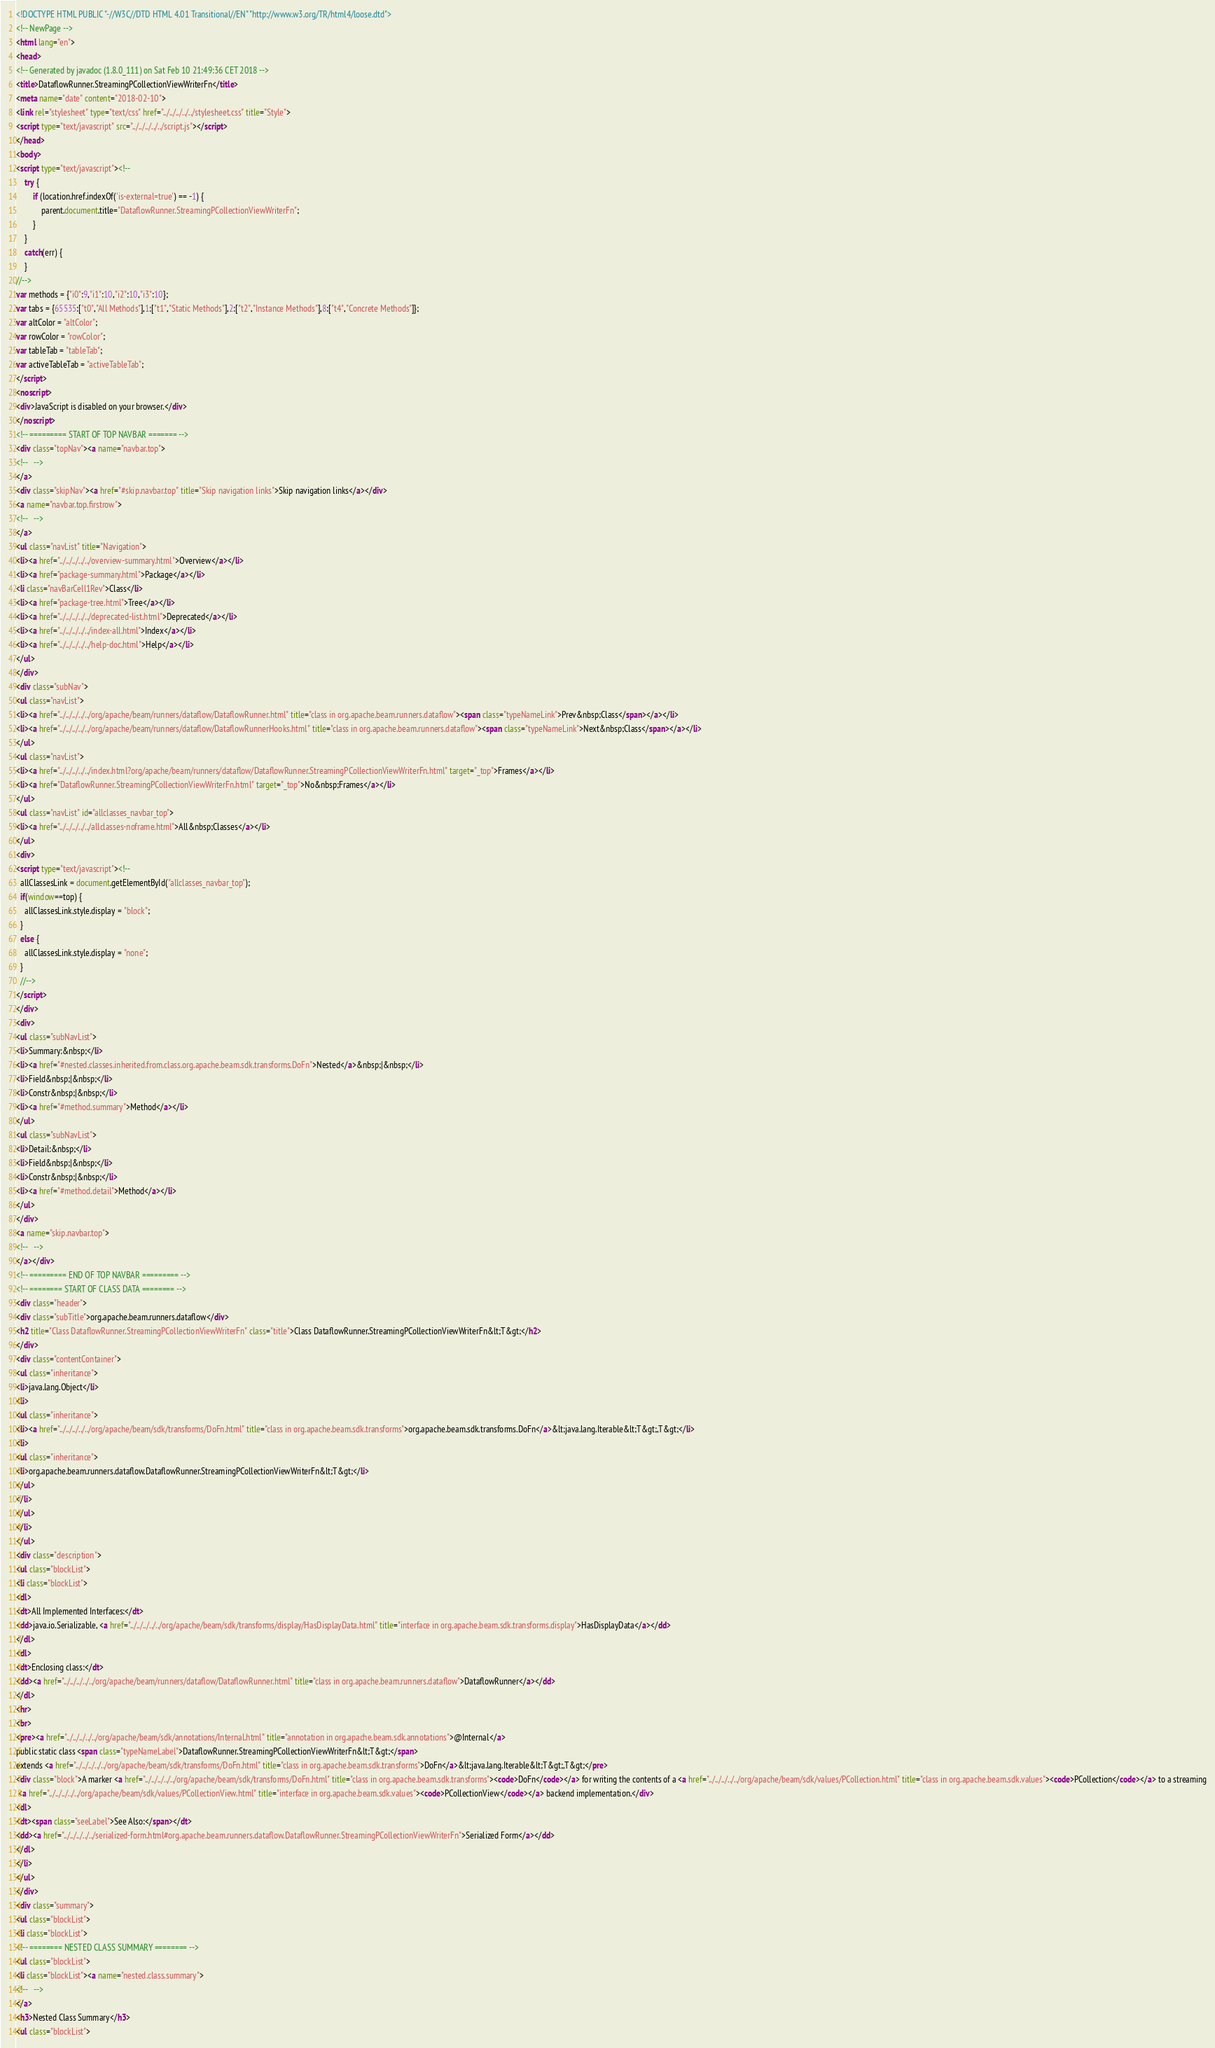<code> <loc_0><loc_0><loc_500><loc_500><_HTML_><!DOCTYPE HTML PUBLIC "-//W3C//DTD HTML 4.01 Transitional//EN" "http://www.w3.org/TR/html4/loose.dtd">
<!-- NewPage -->
<html lang="en">
<head>
<!-- Generated by javadoc (1.8.0_111) on Sat Feb 10 21:49:36 CET 2018 -->
<title>DataflowRunner.StreamingPCollectionViewWriterFn</title>
<meta name="date" content="2018-02-10">
<link rel="stylesheet" type="text/css" href="../../../../../stylesheet.css" title="Style">
<script type="text/javascript" src="../../../../../script.js"></script>
</head>
<body>
<script type="text/javascript"><!--
    try {
        if (location.href.indexOf('is-external=true') == -1) {
            parent.document.title="DataflowRunner.StreamingPCollectionViewWriterFn";
        }
    }
    catch(err) {
    }
//-->
var methods = {"i0":9,"i1":10,"i2":10,"i3":10};
var tabs = {65535:["t0","All Methods"],1:["t1","Static Methods"],2:["t2","Instance Methods"],8:["t4","Concrete Methods"]};
var altColor = "altColor";
var rowColor = "rowColor";
var tableTab = "tableTab";
var activeTableTab = "activeTableTab";
</script>
<noscript>
<div>JavaScript is disabled on your browser.</div>
</noscript>
<!-- ========= START OF TOP NAVBAR ======= -->
<div class="topNav"><a name="navbar.top">
<!--   -->
</a>
<div class="skipNav"><a href="#skip.navbar.top" title="Skip navigation links">Skip navigation links</a></div>
<a name="navbar.top.firstrow">
<!--   -->
</a>
<ul class="navList" title="Navigation">
<li><a href="../../../../../overview-summary.html">Overview</a></li>
<li><a href="package-summary.html">Package</a></li>
<li class="navBarCell1Rev">Class</li>
<li><a href="package-tree.html">Tree</a></li>
<li><a href="../../../../../deprecated-list.html">Deprecated</a></li>
<li><a href="../../../../../index-all.html">Index</a></li>
<li><a href="../../../../../help-doc.html">Help</a></li>
</ul>
</div>
<div class="subNav">
<ul class="navList">
<li><a href="../../../../../org/apache/beam/runners/dataflow/DataflowRunner.html" title="class in org.apache.beam.runners.dataflow"><span class="typeNameLink">Prev&nbsp;Class</span></a></li>
<li><a href="../../../../../org/apache/beam/runners/dataflow/DataflowRunnerHooks.html" title="class in org.apache.beam.runners.dataflow"><span class="typeNameLink">Next&nbsp;Class</span></a></li>
</ul>
<ul class="navList">
<li><a href="../../../../../index.html?org/apache/beam/runners/dataflow/DataflowRunner.StreamingPCollectionViewWriterFn.html" target="_top">Frames</a></li>
<li><a href="DataflowRunner.StreamingPCollectionViewWriterFn.html" target="_top">No&nbsp;Frames</a></li>
</ul>
<ul class="navList" id="allclasses_navbar_top">
<li><a href="../../../../../allclasses-noframe.html">All&nbsp;Classes</a></li>
</ul>
<div>
<script type="text/javascript"><!--
  allClassesLink = document.getElementById("allclasses_navbar_top");
  if(window==top) {
    allClassesLink.style.display = "block";
  }
  else {
    allClassesLink.style.display = "none";
  }
  //-->
</script>
</div>
<div>
<ul class="subNavList">
<li>Summary:&nbsp;</li>
<li><a href="#nested.classes.inherited.from.class.org.apache.beam.sdk.transforms.DoFn">Nested</a>&nbsp;|&nbsp;</li>
<li>Field&nbsp;|&nbsp;</li>
<li>Constr&nbsp;|&nbsp;</li>
<li><a href="#method.summary">Method</a></li>
</ul>
<ul class="subNavList">
<li>Detail:&nbsp;</li>
<li>Field&nbsp;|&nbsp;</li>
<li>Constr&nbsp;|&nbsp;</li>
<li><a href="#method.detail">Method</a></li>
</ul>
</div>
<a name="skip.navbar.top">
<!--   -->
</a></div>
<!-- ========= END OF TOP NAVBAR ========= -->
<!-- ======== START OF CLASS DATA ======== -->
<div class="header">
<div class="subTitle">org.apache.beam.runners.dataflow</div>
<h2 title="Class DataflowRunner.StreamingPCollectionViewWriterFn" class="title">Class DataflowRunner.StreamingPCollectionViewWriterFn&lt;T&gt;</h2>
</div>
<div class="contentContainer">
<ul class="inheritance">
<li>java.lang.Object</li>
<li>
<ul class="inheritance">
<li><a href="../../../../../org/apache/beam/sdk/transforms/DoFn.html" title="class in org.apache.beam.sdk.transforms">org.apache.beam.sdk.transforms.DoFn</a>&lt;java.lang.Iterable&lt;T&gt;,T&gt;</li>
<li>
<ul class="inheritance">
<li>org.apache.beam.runners.dataflow.DataflowRunner.StreamingPCollectionViewWriterFn&lt;T&gt;</li>
</ul>
</li>
</ul>
</li>
</ul>
<div class="description">
<ul class="blockList">
<li class="blockList">
<dl>
<dt>All Implemented Interfaces:</dt>
<dd>java.io.Serializable, <a href="../../../../../org/apache/beam/sdk/transforms/display/HasDisplayData.html" title="interface in org.apache.beam.sdk.transforms.display">HasDisplayData</a></dd>
</dl>
<dl>
<dt>Enclosing class:</dt>
<dd><a href="../../../../../org/apache/beam/runners/dataflow/DataflowRunner.html" title="class in org.apache.beam.runners.dataflow">DataflowRunner</a></dd>
</dl>
<hr>
<br>
<pre><a href="../../../../../org/apache/beam/sdk/annotations/Internal.html" title="annotation in org.apache.beam.sdk.annotations">@Internal</a>
public static class <span class="typeNameLabel">DataflowRunner.StreamingPCollectionViewWriterFn&lt;T&gt;</span>
extends <a href="../../../../../org/apache/beam/sdk/transforms/DoFn.html" title="class in org.apache.beam.sdk.transforms">DoFn</a>&lt;java.lang.Iterable&lt;T&gt;,T&gt;</pre>
<div class="block">A marker <a href="../../../../../org/apache/beam/sdk/transforms/DoFn.html" title="class in org.apache.beam.sdk.transforms"><code>DoFn</code></a> for writing the contents of a <a href="../../../../../org/apache/beam/sdk/values/PCollection.html" title="class in org.apache.beam.sdk.values"><code>PCollection</code></a> to a streaming
 <a href="../../../../../org/apache/beam/sdk/values/PCollectionView.html" title="interface in org.apache.beam.sdk.values"><code>PCollectionView</code></a> backend implementation.</div>
<dl>
<dt><span class="seeLabel">See Also:</span></dt>
<dd><a href="../../../../../serialized-form.html#org.apache.beam.runners.dataflow.DataflowRunner.StreamingPCollectionViewWriterFn">Serialized Form</a></dd>
</dl>
</li>
</ul>
</div>
<div class="summary">
<ul class="blockList">
<li class="blockList">
<!-- ======== NESTED CLASS SUMMARY ======== -->
<ul class="blockList">
<li class="blockList"><a name="nested.class.summary">
<!--   -->
</a>
<h3>Nested Class Summary</h3>
<ul class="blockList"></code> 